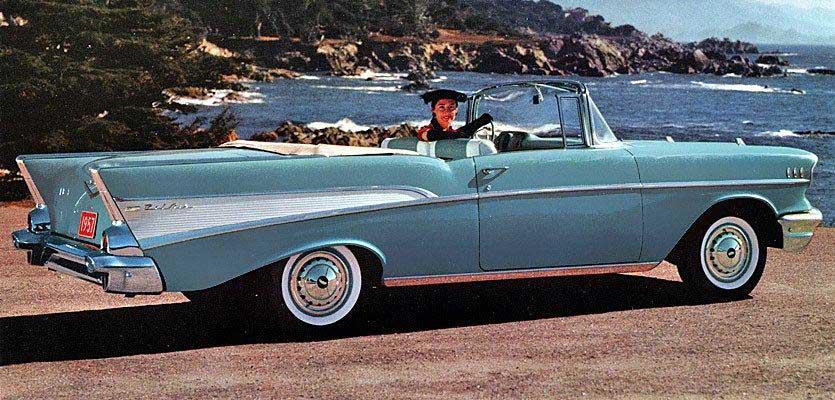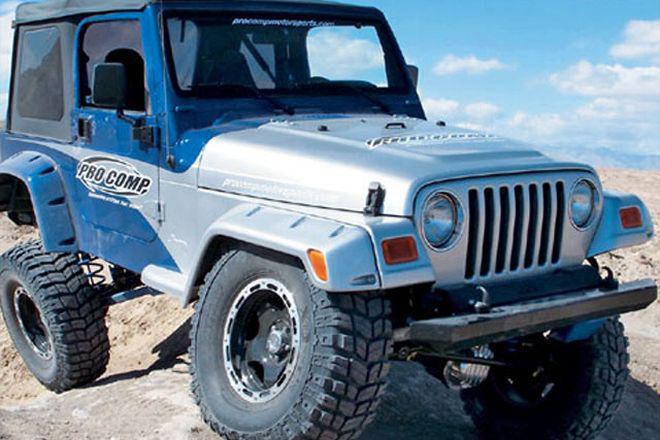The first image is the image on the left, the second image is the image on the right. Evaluate the accuracy of this statement regarding the images: "Both vehicles are Jeep Wranglers.". Is it true? Answer yes or no. No. The first image is the image on the left, the second image is the image on the right. Assess this claim about the two images: "there are two jeeps in the image pair facing each other". Correct or not? Answer yes or no. No. 